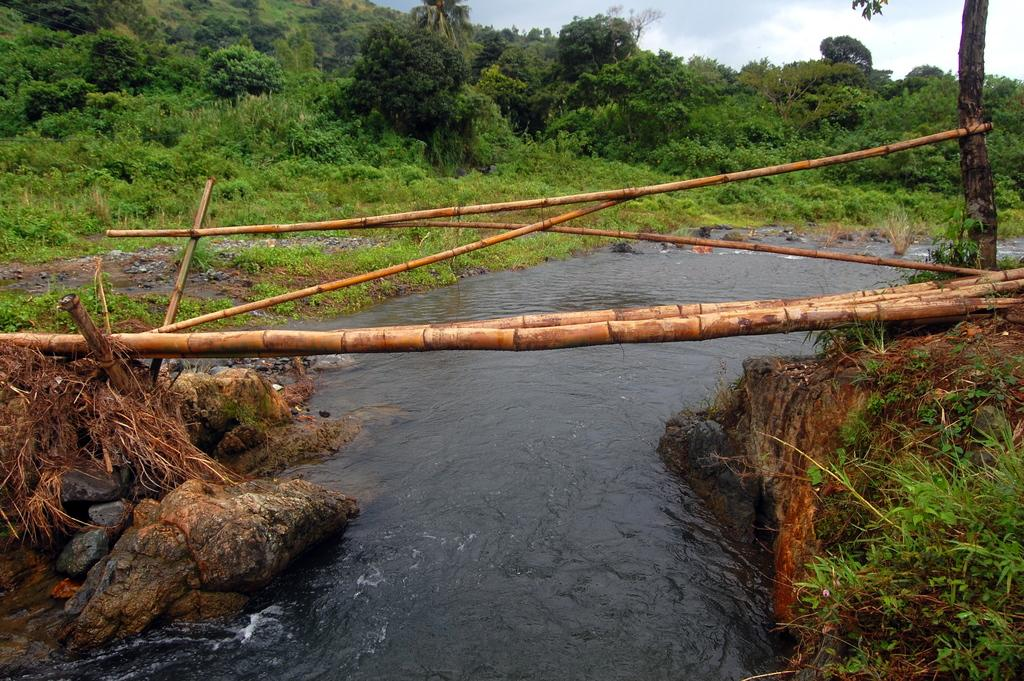What is visible in the image? There is water visible in the image. What can be seen in the background of the image? There are plants or trees in the background of the image. What type of reward can be seen hanging from the tree in the image? There is no reward or tree present in the image; it only features water and plants or trees in the background. 